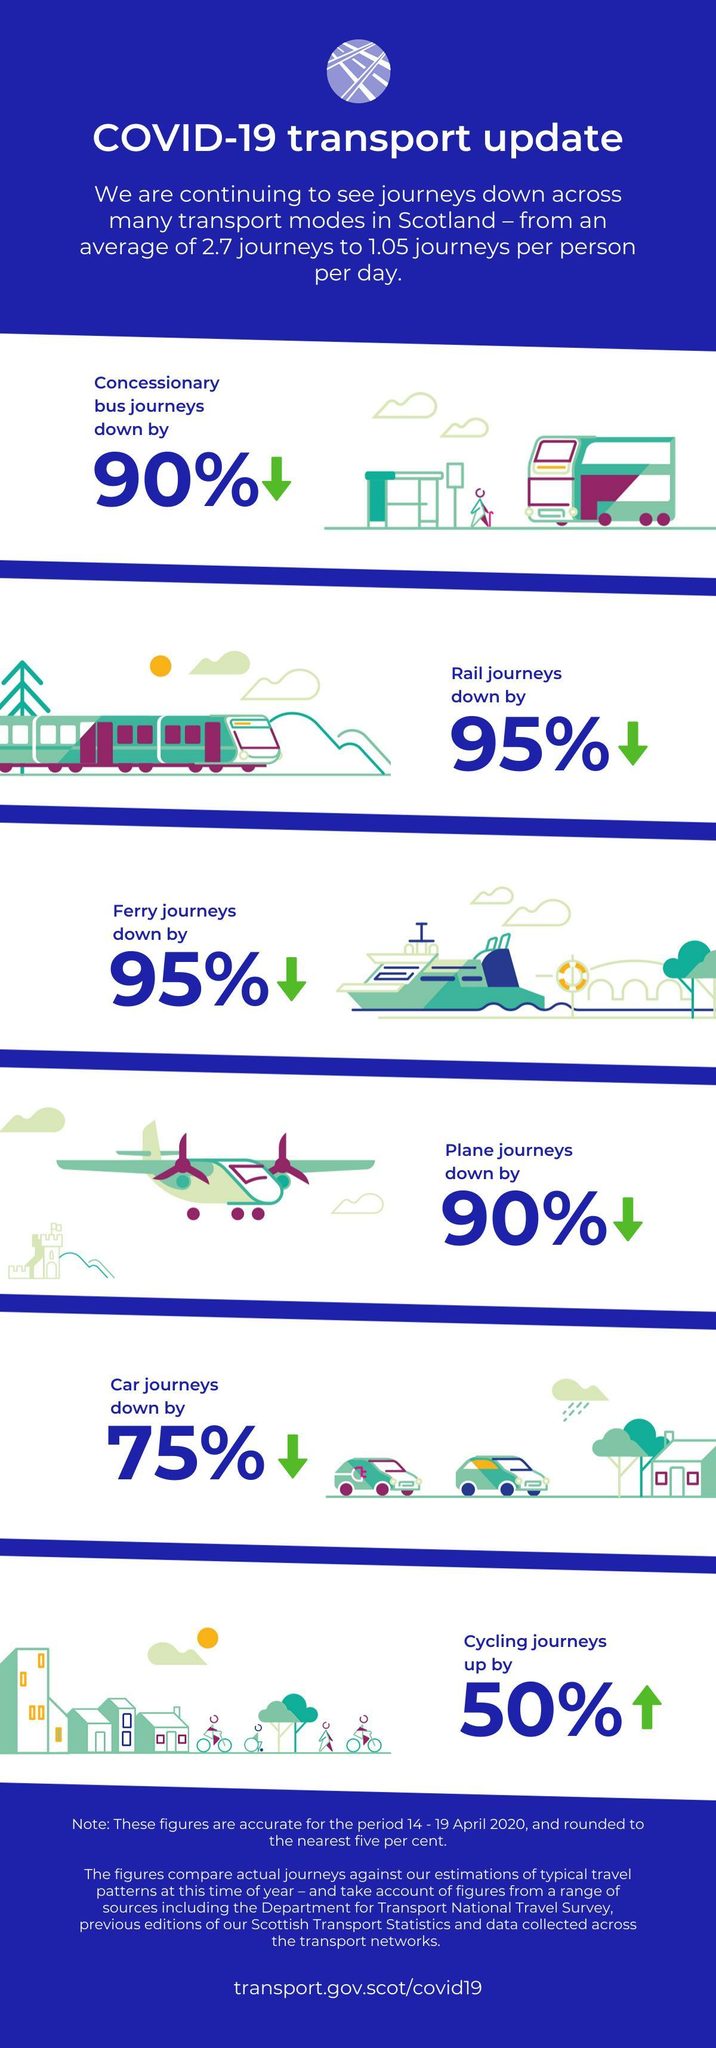What are the different types of road transport in this infographic?
Answer the question with a short phrase. bus, car, cycling 